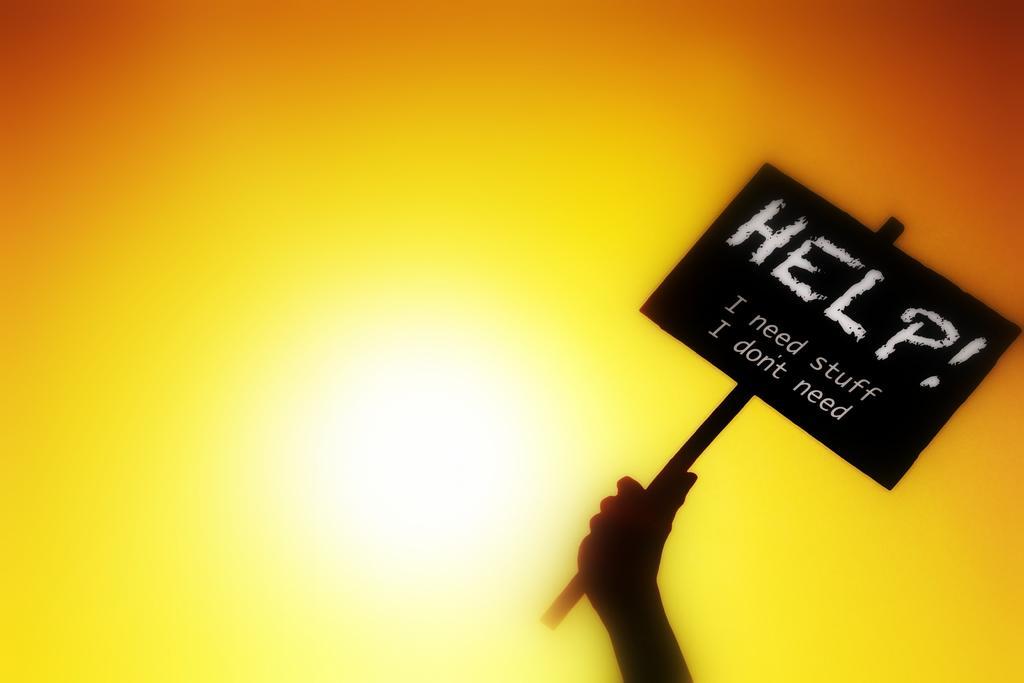Please provide a concise description of this image. In this image I can see a person holding a blackboard with some text written on it. In the background, I can see white, yellow and orange color. 